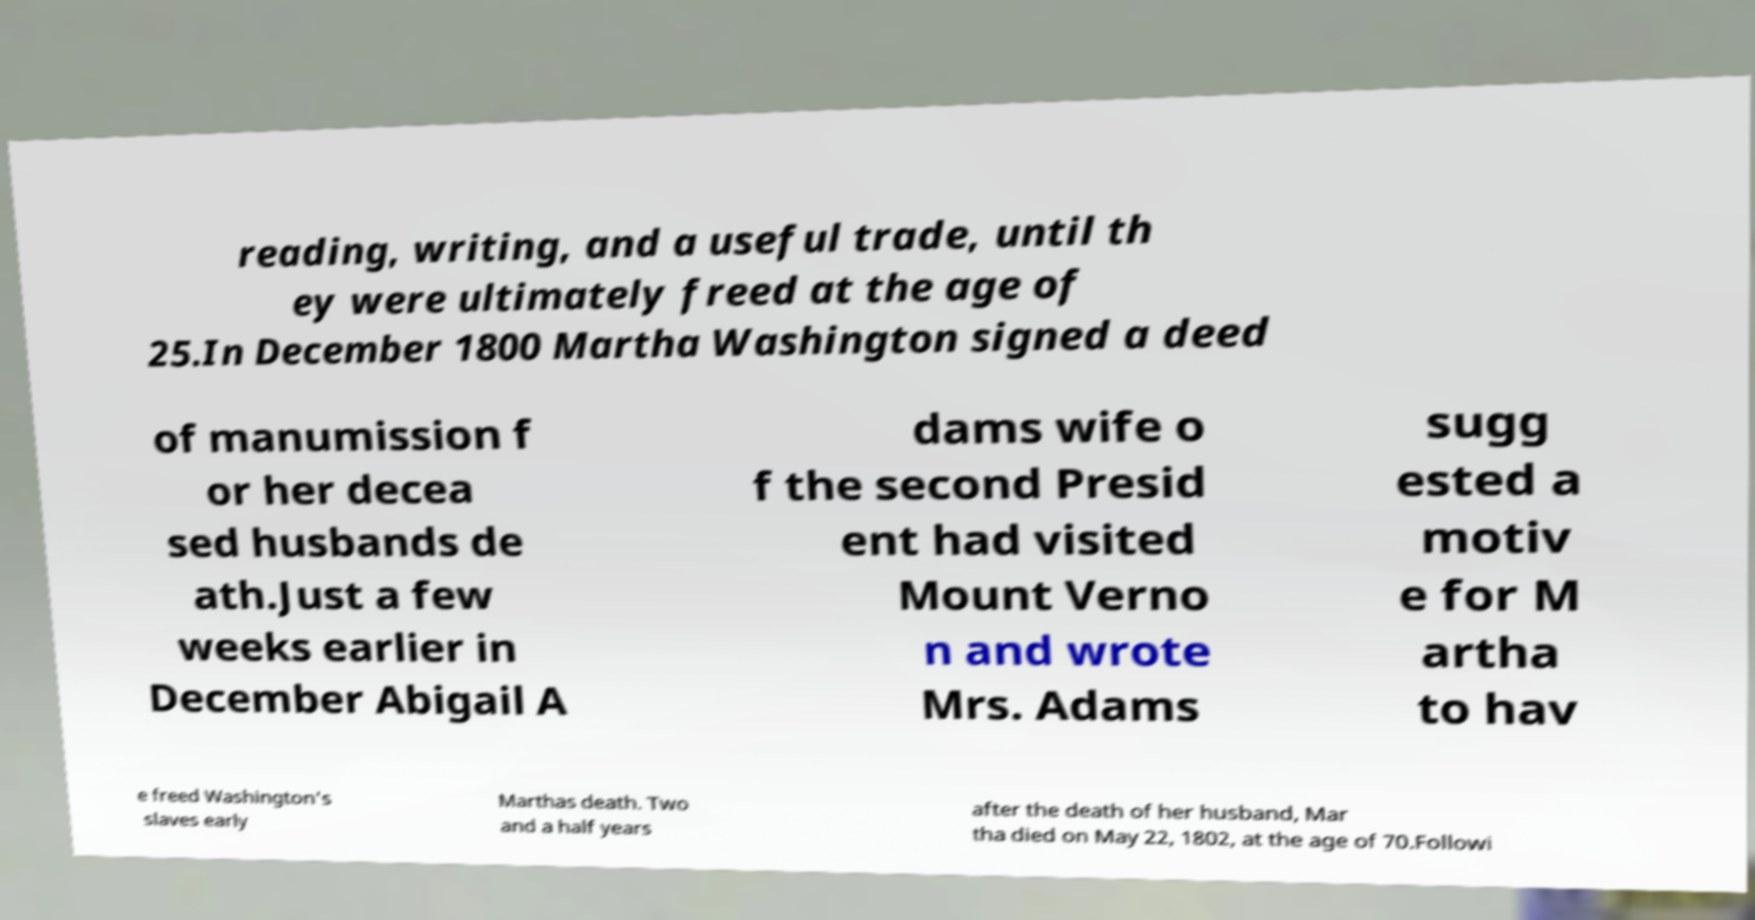Please identify and transcribe the text found in this image. reading, writing, and a useful trade, until th ey were ultimately freed at the age of 25.In December 1800 Martha Washington signed a deed of manumission f or her decea sed husbands de ath.Just a few weeks earlier in December Abigail A dams wife o f the second Presid ent had visited Mount Verno n and wrote Mrs. Adams sugg ested a motiv e for M artha to hav e freed Washington's slaves early Marthas death. Two and a half years after the death of her husband, Mar tha died on May 22, 1802, at the age of 70.Followi 